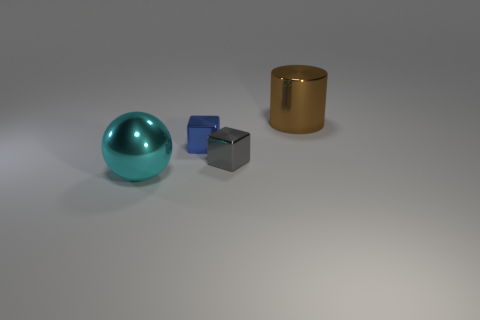Add 2 tiny green blocks. How many objects exist? 6 Subtract all balls. How many objects are left? 3 Add 3 brown cylinders. How many brown cylinders are left? 4 Add 2 metal cylinders. How many metal cylinders exist? 3 Subtract 0 red balls. How many objects are left? 4 Subtract all blue things. Subtract all big cyan metal objects. How many objects are left? 2 